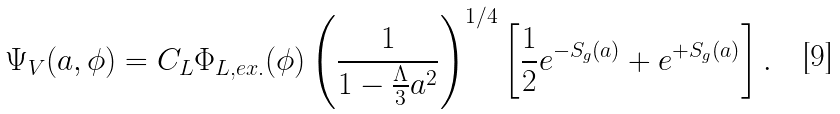<formula> <loc_0><loc_0><loc_500><loc_500>\Psi _ { V } ( a , \phi ) = C _ { L } \Phi _ { L , e x . } ( \phi ) \left ( \frac { 1 } { 1 - \frac { \Lambda } { 3 } a ^ { 2 } } \right ) ^ { 1 / 4 } \left [ \frac { 1 } { 2 } e ^ { - S _ { g } ( a ) } + e ^ { + S _ { g } ( a ) } \right ] .</formula> 